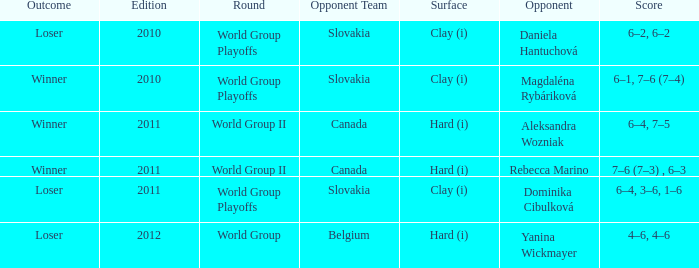What was the game edition during their play on the clay (i) surface, which led to a winning outcome? 2010.0. 